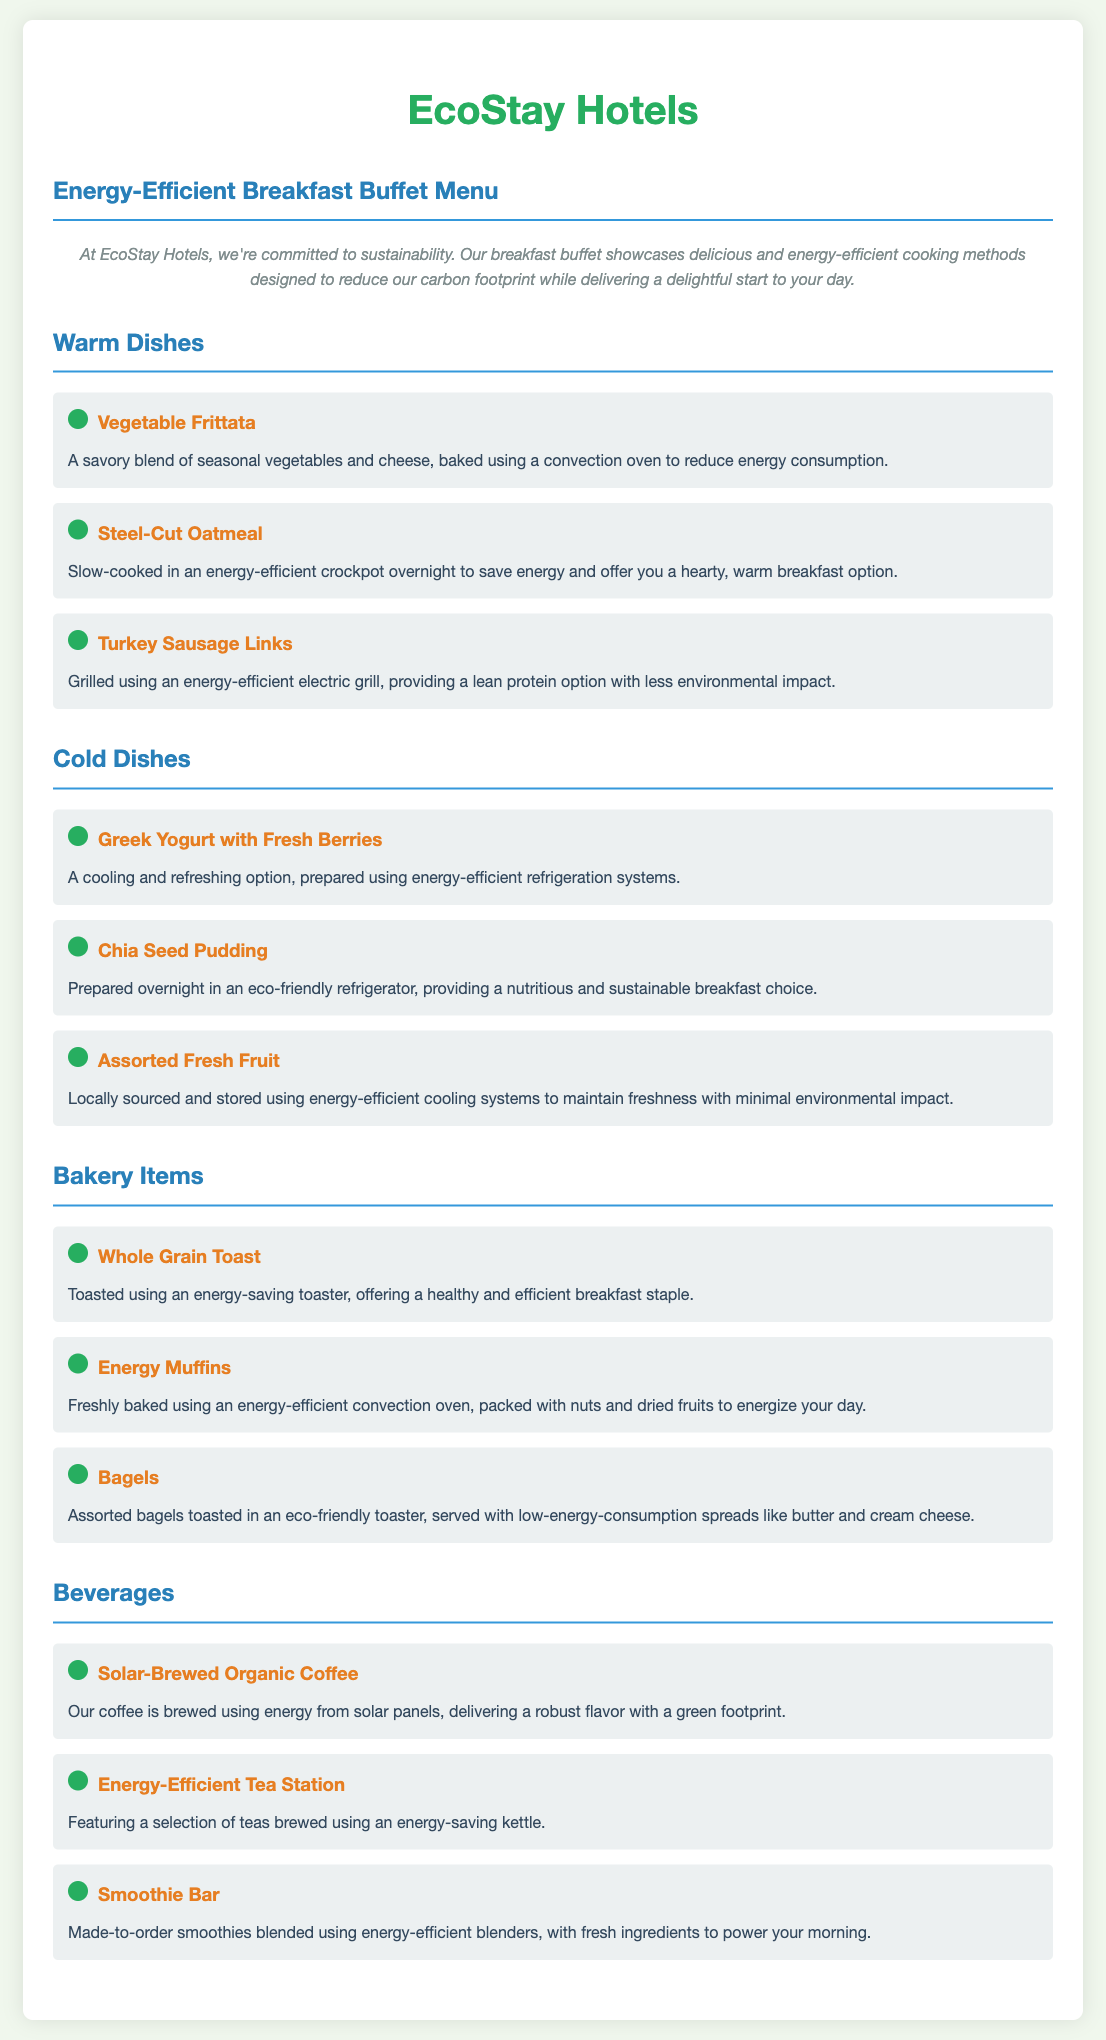what is the title of the document? The title appears at the top of the rendered document and states the purpose and theme of the content.
Answer: Energy-Efficient Breakfast Buffet Menu how many warm dishes are listed? The document categorizes dishes, and the warm dishes section lists each item. Counting those items gives the total.
Answer: 3 what cooking method is used for the Vegetable Frittata? The cooking method is specified in the description of the dish, indicating how it is prepared.
Answer: Convection oven what is the main ingredient in the Steel-Cut Oatmeal? The name of the dish itself indicates its primary component, which is important for dietary considerations.
Answer: Oatmeal which beverage is made from solar energy? The document specifies the beverages and their preparation methods, indicating which one utilizes solar energy.
Answer: Solar-Brewed Organic Coffee what type of baking method is mentioned for the Energy Muffins? The method of baking is highlighted in the description of the dish, which informs readers about its energy usage.
Answer: Energy-efficient convection oven what elective nutritional option is mentioned in the Cold Dishes section? The dishes categorized under cold options are discussed, indicating which ones are suitable for healthy diets.
Answer: Greek Yogurt with Fresh Berries what items are served with the Bagels? The document describes what accompaniments come with the bagels, relevant for meals and dietary preferences.
Answer: Low-energy-consumption spreads like butter and cream cheese how are the Chia Seed Pudding and Assorted Fresh Fruit prepared? The descriptions in the document give insight into how these dishes are prepared and their environmental considerations.
Answer: Eco-friendly refrigeration what is a key characteristic of the Smoothie Bar? The document outlines the unique aspects of the beverage options, highlighting energy efficiency as a feature.
Answer: Energy-efficient blenders 